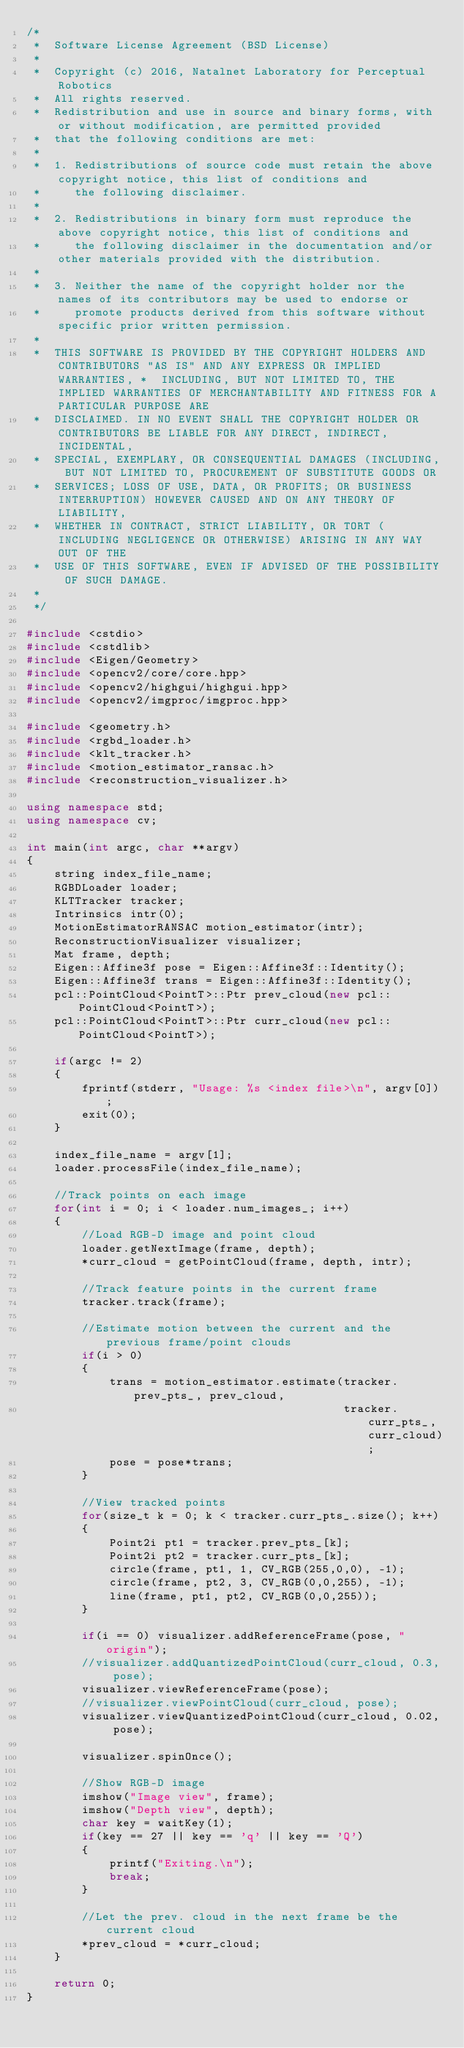<code> <loc_0><loc_0><loc_500><loc_500><_C++_>/* 
 *  Software License Agreement (BSD License)
 *
 *  Copyright (c) 2016, Natalnet Laboratory for Perceptual Robotics
 *  All rights reserved.
 *  Redistribution and use in source and binary forms, with or without modification, are permitted provided
 *  that the following conditions are met:
 *
 *  1. Redistributions of source code must retain the above copyright notice, this list of conditions and
 *     the following disclaimer.
 *
 *  2. Redistributions in binary form must reproduce the above copyright notice, this list of conditions and
 *     the following disclaimer in the documentation and/or other materials provided with the distribution.
 * 
 *  3. Neither the name of the copyright holder nor the names of its contributors may be used to endorse or
 *     promote products derived from this software without specific prior written permission.
 * 
 *  THIS SOFTWARE IS PROVIDED BY THE COPYRIGHT HOLDERS AND CONTRIBUTORS "AS IS" AND ANY EXPRESS OR IMPLIED WARRANTIES, *  INCLUDING, BUT NOT LIMITED TO, THE IMPLIED WARRANTIES OF MERCHANTABILITY AND FITNESS FOR A PARTICULAR PURPOSE ARE
 *  DISCLAIMED. IN NO EVENT SHALL THE COPYRIGHT HOLDER OR CONTRIBUTORS BE LIABLE FOR ANY DIRECT, INDIRECT, INCIDENTAL,
 *  SPECIAL, EXEMPLARY, OR CONSEQUENTIAL DAMAGES (INCLUDING, BUT NOT LIMITED TO, PROCUREMENT OF SUBSTITUTE GOODS OR
 *  SERVICES; LOSS OF USE, DATA, OR PROFITS; OR BUSINESS INTERRUPTION) HOWEVER CAUSED AND ON ANY THEORY OF LIABILITY,
 *  WHETHER IN CONTRACT, STRICT LIABILITY, OR TORT (INCLUDING NEGLIGENCE OR OTHERWISE) ARISING IN ANY WAY OUT OF THE
 *  USE OF THIS SOFTWARE, EVEN IF ADVISED OF THE POSSIBILITY OF SUCH DAMAGE.
 *
 */

#include <cstdio>
#include <cstdlib>
#include <Eigen/Geometry>
#include <opencv2/core/core.hpp>
#include <opencv2/highgui/highgui.hpp>
#include <opencv2/imgproc/imgproc.hpp>

#include <geometry.h>
#include <rgbd_loader.h>
#include <klt_tracker.h>
#include <motion_estimator_ransac.h>
#include <reconstruction_visualizer.h>

using namespace std;
using namespace cv;

int main(int argc, char **argv)
{
	string index_file_name;
	RGBDLoader loader;
	KLTTracker tracker;
	Intrinsics intr(0);
	MotionEstimatorRANSAC motion_estimator(intr);
	ReconstructionVisualizer visualizer;
	Mat frame, depth;
	Eigen::Affine3f pose = Eigen::Affine3f::Identity();
	Eigen::Affine3f trans = Eigen::Affine3f::Identity();
	pcl::PointCloud<PointT>::Ptr prev_cloud(new pcl::PointCloud<PointT>);
	pcl::PointCloud<PointT>::Ptr curr_cloud(new pcl::PointCloud<PointT>);

	if(argc != 2)
	{
		fprintf(stderr, "Usage: %s <index file>\n", argv[0]);
		exit(0);
	}

	index_file_name = argv[1];
	loader.processFile(index_file_name);

	//Track points on each image
	for(int i = 0; i < loader.num_images_; i++)
	{
		//Load RGB-D image and point cloud 
		loader.getNextImage(frame, depth);
		*curr_cloud = getPointCloud(frame, depth, intr);

		//Track feature points in the current frame
		tracker.track(frame);

		//Estimate motion between the current and the previous frame/point clouds
		if(i > 0)
		{
			trans = motion_estimator.estimate(tracker.prev_pts_, prev_cloud,
				                              tracker.curr_pts_, curr_cloud);
			pose = pose*trans;
		}

		//View tracked points
		for(size_t k = 0; k < tracker.curr_pts_.size(); k++)
		{
			Point2i pt1 = tracker.prev_pts_[k];
			Point2i pt2 = tracker.curr_pts_[k];
			circle(frame, pt1, 1, CV_RGB(255,0,0), -1);
			circle(frame, pt2, 3, CV_RGB(0,0,255), -1);
			line(frame, pt1, pt2, CV_RGB(0,0,255));
		}

		if(i == 0) visualizer.addReferenceFrame(pose, "origin");
		//visualizer.addQuantizedPointCloud(curr_cloud, 0.3, pose);
		visualizer.viewReferenceFrame(pose);
		//visualizer.viewPointCloud(curr_cloud, pose);
		visualizer.viewQuantizedPointCloud(curr_cloud, 0.02, pose);

		visualizer.spinOnce();

		//Show RGB-D image
		imshow("Image view", frame);
		imshow("Depth view", depth);
		char key = waitKey(1);
		if(key == 27 || key == 'q' || key == 'Q')
		{
			printf("Exiting.\n");
			break;
		}

		//Let the prev. cloud in the next frame be the current cloud
		*prev_cloud = *curr_cloud;
	}

	return 0;
}</code> 